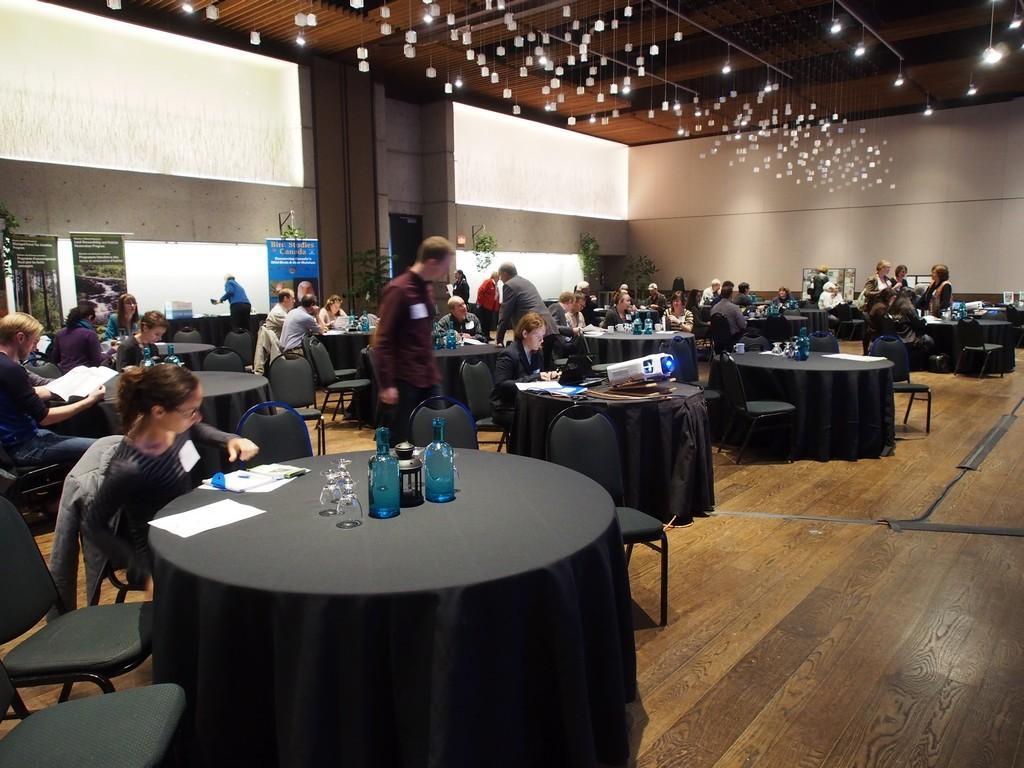Please provide a concise description of this image. Few people standing and few people are sitting on chairs. We can see bottles, projector, papers, glasses and some object on tables. In the background we can see banners, plants and walls. At the top we can see lights. 